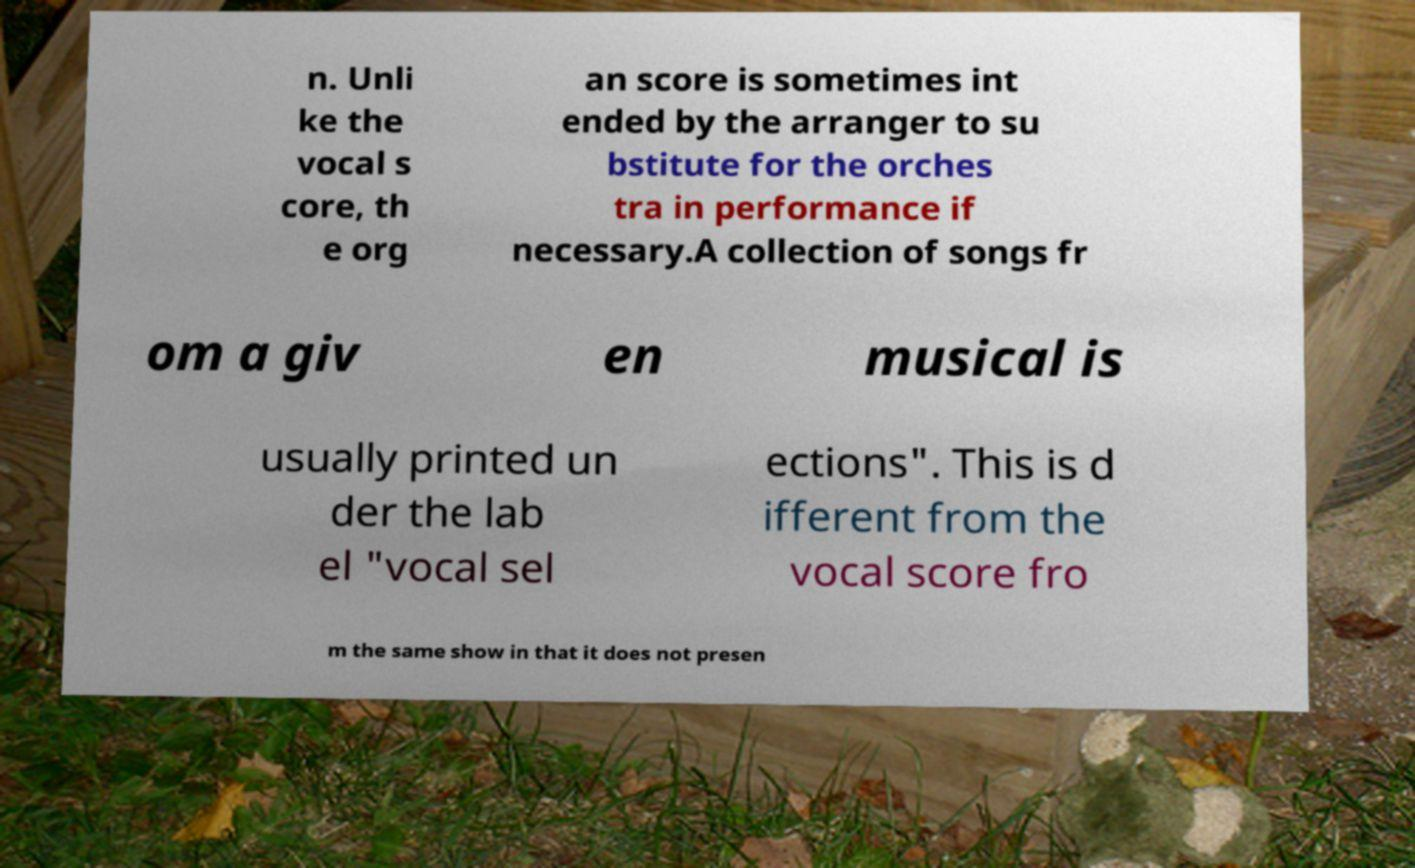Can you read and provide the text displayed in the image?This photo seems to have some interesting text. Can you extract and type it out for me? n. Unli ke the vocal s core, th e org an score is sometimes int ended by the arranger to su bstitute for the orches tra in performance if necessary.A collection of songs fr om a giv en musical is usually printed un der the lab el "vocal sel ections". This is d ifferent from the vocal score fro m the same show in that it does not presen 